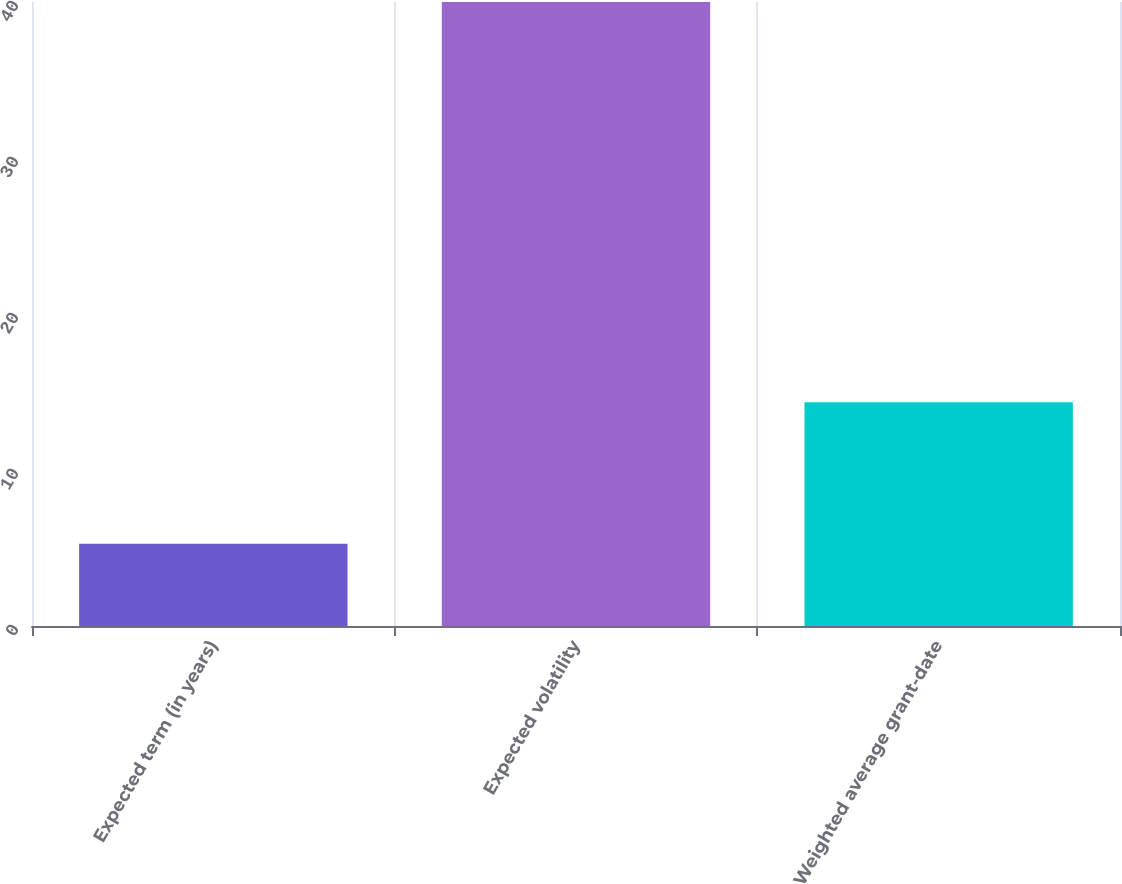<chart> <loc_0><loc_0><loc_500><loc_500><bar_chart><fcel>Expected term (in years)<fcel>Expected volatility<fcel>Weighted average grant-date<nl><fcel>5.27<fcel>40<fcel>14.34<nl></chart> 